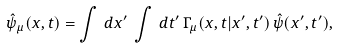<formula> <loc_0><loc_0><loc_500><loc_500>\hat { \psi } _ { \mu } ( x , t ) = \int \, d x ^ { \prime } \, \int \, d t ^ { \prime } \, \Gamma _ { \mu } ( x , t | x ^ { \prime } , t ^ { \prime } ) \, \hat { \psi } ( x ^ { \prime } , t ^ { \prime } ) ,</formula> 